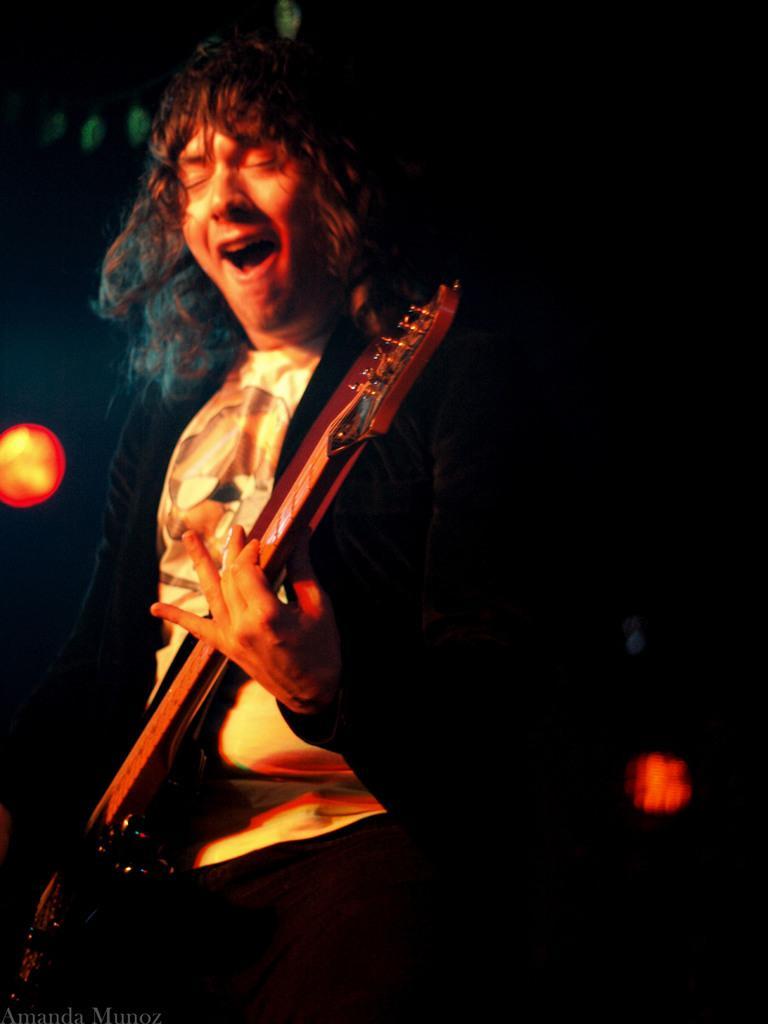Could you give a brief overview of what you see in this image? In this picture we can see a man who is playing guitar. And this is light. 